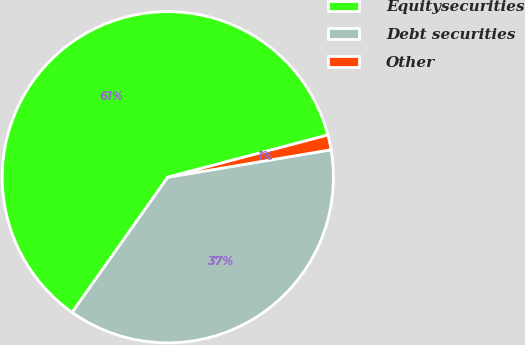Convert chart. <chart><loc_0><loc_0><loc_500><loc_500><pie_chart><fcel>Equitysecurities<fcel>Debt securities<fcel>Other<nl><fcel>61.1%<fcel>37.45%<fcel>1.45%<nl></chart> 